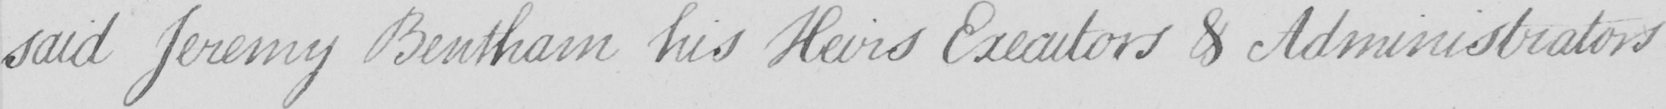What is written in this line of handwriting? said Jeremy Bentham his Heirs Executors & Administrators 